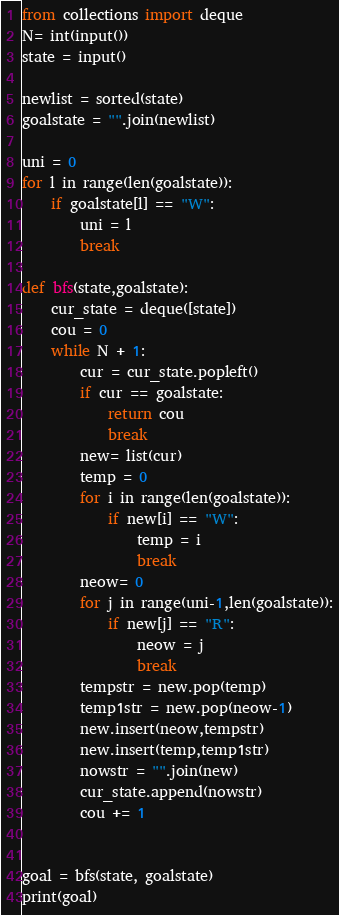Convert code to text. <code><loc_0><loc_0><loc_500><loc_500><_Python_>from collections import deque
N= int(input())
state = input()

newlist = sorted(state)
goalstate = "".join(newlist)

uni = 0
for l in range(len(goalstate)):
    if goalstate[l] == "W":
        uni = l
        break

def bfs(state,goalstate):
    cur_state = deque([state])
    cou = 0
    while N + 1:
        cur = cur_state.popleft()
        if cur == goalstate:
            return cou
            break
        new= list(cur)
        temp = 0
        for i in range(len(goalstate)):
            if new[i] == "W":
                temp = i
                break
        neow= 0
        for j in range(uni-1,len(goalstate)):
            if new[j] == "R":
                neow = j
                break
        tempstr = new.pop(temp)
        temp1str = new.pop(neow-1)
        new.insert(neow,tempstr)
        new.insert(temp,temp1str)
        nowstr = "".join(new)
        cur_state.append(nowstr)
        cou += 1


goal = bfs(state, goalstate)
print(goal)</code> 